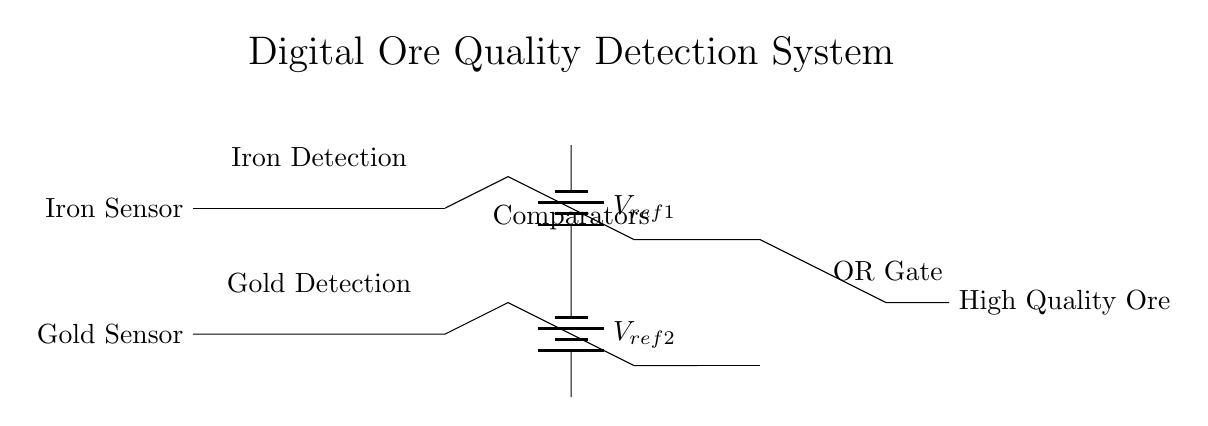What are the two input sensors in the circuit? The input sensors are named Iron Sensor and Gold Sensor, which are labeled explicitly on the circuit diagram.
Answer: Iron Sensor, Gold Sensor What type of logic gate is used to combine the output of the comparators? The circuit uses an OR gate to combine the outputs of the two comparators, as indicated by the symbol in the diagram.
Answer: OR gate How many comparators are present in the circuit? There are two comparators in the circuit, one for each input sensor, as shown by the two op-amp symbols.
Answer: 2 What is the function of the reference voltages? The reference voltages serve as thresholds for the comparators to determine if the input signals indicate high-quality ore.
Answer: Thresholds Which component indicates high-quality ore in the circuit? The output of the OR gate indicates high-quality ore, which is denoted in the circuit as "High Quality Ore."
Answer: OR gate output What voltage levels do the reference voltages represent? The reference voltages are represented as V_ref1 and V_ref2, which are labeled on the batteries in the circuit.
Answer: V_ref1, V_ref2 What type of circuit is this system classified as? This is classified as a digital detection system because it uses logic gates and comparators to process digital signals from the sensors.
Answer: Digital detection system 